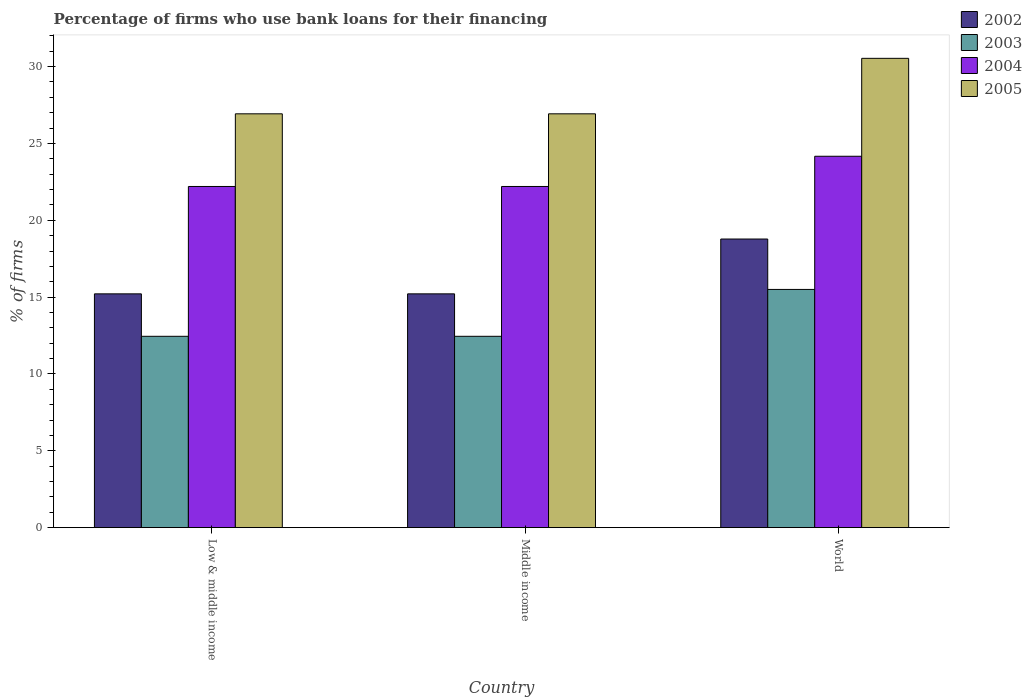How many different coloured bars are there?
Your answer should be very brief. 4. In how many cases, is the number of bars for a given country not equal to the number of legend labels?
Offer a very short reply. 0. What is the percentage of firms who use bank loans for their financing in 2003 in Low & middle income?
Offer a very short reply. 12.45. Across all countries, what is the maximum percentage of firms who use bank loans for their financing in 2003?
Your answer should be very brief. 15.5. Across all countries, what is the minimum percentage of firms who use bank loans for their financing in 2002?
Offer a very short reply. 15.21. In which country was the percentage of firms who use bank loans for their financing in 2003 maximum?
Provide a succinct answer. World. In which country was the percentage of firms who use bank loans for their financing in 2003 minimum?
Offer a terse response. Low & middle income. What is the total percentage of firms who use bank loans for their financing in 2005 in the graph?
Make the answer very short. 84.39. What is the difference between the percentage of firms who use bank loans for their financing in 2005 in Low & middle income and that in World?
Your answer should be compact. -3.61. What is the difference between the percentage of firms who use bank loans for their financing in 2005 in World and the percentage of firms who use bank loans for their financing in 2003 in Low & middle income?
Keep it short and to the point. 18.09. What is the average percentage of firms who use bank loans for their financing in 2004 per country?
Keep it short and to the point. 22.86. What is the difference between the percentage of firms who use bank loans for their financing of/in 2003 and percentage of firms who use bank loans for their financing of/in 2005 in Middle income?
Provide a succinct answer. -14.48. What is the ratio of the percentage of firms who use bank loans for their financing in 2003 in Low & middle income to that in World?
Keep it short and to the point. 0.8. What is the difference between the highest and the second highest percentage of firms who use bank loans for their financing in 2005?
Offer a terse response. -3.61. What is the difference between the highest and the lowest percentage of firms who use bank loans for their financing in 2004?
Keep it short and to the point. 1.97. Is the sum of the percentage of firms who use bank loans for their financing in 2005 in Low & middle income and World greater than the maximum percentage of firms who use bank loans for their financing in 2004 across all countries?
Keep it short and to the point. Yes. What does the 2nd bar from the right in Low & middle income represents?
Make the answer very short. 2004. Is it the case that in every country, the sum of the percentage of firms who use bank loans for their financing in 2003 and percentage of firms who use bank loans for their financing in 2005 is greater than the percentage of firms who use bank loans for their financing in 2004?
Ensure brevity in your answer.  Yes. What is the difference between two consecutive major ticks on the Y-axis?
Your answer should be very brief. 5. How many legend labels are there?
Your answer should be very brief. 4. How are the legend labels stacked?
Give a very brief answer. Vertical. What is the title of the graph?
Provide a succinct answer. Percentage of firms who use bank loans for their financing. Does "2000" appear as one of the legend labels in the graph?
Offer a terse response. No. What is the label or title of the Y-axis?
Your response must be concise. % of firms. What is the % of firms of 2002 in Low & middle income?
Your response must be concise. 15.21. What is the % of firms in 2003 in Low & middle income?
Ensure brevity in your answer.  12.45. What is the % of firms of 2005 in Low & middle income?
Make the answer very short. 26.93. What is the % of firms of 2002 in Middle income?
Your answer should be compact. 15.21. What is the % of firms in 2003 in Middle income?
Give a very brief answer. 12.45. What is the % of firms of 2004 in Middle income?
Provide a short and direct response. 22.2. What is the % of firms in 2005 in Middle income?
Your answer should be very brief. 26.93. What is the % of firms of 2002 in World?
Your answer should be very brief. 18.78. What is the % of firms in 2004 in World?
Provide a succinct answer. 24.17. What is the % of firms of 2005 in World?
Provide a short and direct response. 30.54. Across all countries, what is the maximum % of firms in 2002?
Provide a short and direct response. 18.78. Across all countries, what is the maximum % of firms of 2003?
Provide a succinct answer. 15.5. Across all countries, what is the maximum % of firms in 2004?
Offer a terse response. 24.17. Across all countries, what is the maximum % of firms in 2005?
Your response must be concise. 30.54. Across all countries, what is the minimum % of firms in 2002?
Your answer should be very brief. 15.21. Across all countries, what is the minimum % of firms of 2003?
Offer a very short reply. 12.45. Across all countries, what is the minimum % of firms of 2005?
Offer a very short reply. 26.93. What is the total % of firms of 2002 in the graph?
Provide a short and direct response. 49.21. What is the total % of firms in 2003 in the graph?
Your answer should be compact. 40.4. What is the total % of firms in 2004 in the graph?
Give a very brief answer. 68.57. What is the total % of firms in 2005 in the graph?
Offer a very short reply. 84.39. What is the difference between the % of firms in 2004 in Low & middle income and that in Middle income?
Provide a short and direct response. 0. What is the difference between the % of firms of 2002 in Low & middle income and that in World?
Your answer should be very brief. -3.57. What is the difference between the % of firms in 2003 in Low & middle income and that in World?
Make the answer very short. -3.05. What is the difference between the % of firms in 2004 in Low & middle income and that in World?
Give a very brief answer. -1.97. What is the difference between the % of firms of 2005 in Low & middle income and that in World?
Your answer should be very brief. -3.61. What is the difference between the % of firms of 2002 in Middle income and that in World?
Offer a very short reply. -3.57. What is the difference between the % of firms in 2003 in Middle income and that in World?
Offer a terse response. -3.05. What is the difference between the % of firms in 2004 in Middle income and that in World?
Your response must be concise. -1.97. What is the difference between the % of firms of 2005 in Middle income and that in World?
Provide a short and direct response. -3.61. What is the difference between the % of firms of 2002 in Low & middle income and the % of firms of 2003 in Middle income?
Provide a succinct answer. 2.76. What is the difference between the % of firms in 2002 in Low & middle income and the % of firms in 2004 in Middle income?
Offer a terse response. -6.99. What is the difference between the % of firms in 2002 in Low & middle income and the % of firms in 2005 in Middle income?
Provide a succinct answer. -11.72. What is the difference between the % of firms in 2003 in Low & middle income and the % of firms in 2004 in Middle income?
Your answer should be very brief. -9.75. What is the difference between the % of firms of 2003 in Low & middle income and the % of firms of 2005 in Middle income?
Your response must be concise. -14.48. What is the difference between the % of firms of 2004 in Low & middle income and the % of firms of 2005 in Middle income?
Provide a succinct answer. -4.73. What is the difference between the % of firms of 2002 in Low & middle income and the % of firms of 2003 in World?
Your answer should be very brief. -0.29. What is the difference between the % of firms in 2002 in Low & middle income and the % of firms in 2004 in World?
Make the answer very short. -8.95. What is the difference between the % of firms in 2002 in Low & middle income and the % of firms in 2005 in World?
Keep it short and to the point. -15.33. What is the difference between the % of firms in 2003 in Low & middle income and the % of firms in 2004 in World?
Offer a very short reply. -11.72. What is the difference between the % of firms in 2003 in Low & middle income and the % of firms in 2005 in World?
Ensure brevity in your answer.  -18.09. What is the difference between the % of firms in 2004 in Low & middle income and the % of firms in 2005 in World?
Offer a very short reply. -8.34. What is the difference between the % of firms of 2002 in Middle income and the % of firms of 2003 in World?
Offer a very short reply. -0.29. What is the difference between the % of firms of 2002 in Middle income and the % of firms of 2004 in World?
Offer a terse response. -8.95. What is the difference between the % of firms of 2002 in Middle income and the % of firms of 2005 in World?
Make the answer very short. -15.33. What is the difference between the % of firms in 2003 in Middle income and the % of firms in 2004 in World?
Your response must be concise. -11.72. What is the difference between the % of firms of 2003 in Middle income and the % of firms of 2005 in World?
Make the answer very short. -18.09. What is the difference between the % of firms in 2004 in Middle income and the % of firms in 2005 in World?
Ensure brevity in your answer.  -8.34. What is the average % of firms of 2002 per country?
Keep it short and to the point. 16.4. What is the average % of firms of 2003 per country?
Ensure brevity in your answer.  13.47. What is the average % of firms in 2004 per country?
Offer a very short reply. 22.86. What is the average % of firms of 2005 per country?
Offer a terse response. 28.13. What is the difference between the % of firms of 2002 and % of firms of 2003 in Low & middle income?
Offer a very short reply. 2.76. What is the difference between the % of firms of 2002 and % of firms of 2004 in Low & middle income?
Your answer should be very brief. -6.99. What is the difference between the % of firms in 2002 and % of firms in 2005 in Low & middle income?
Your response must be concise. -11.72. What is the difference between the % of firms of 2003 and % of firms of 2004 in Low & middle income?
Give a very brief answer. -9.75. What is the difference between the % of firms in 2003 and % of firms in 2005 in Low & middle income?
Offer a very short reply. -14.48. What is the difference between the % of firms in 2004 and % of firms in 2005 in Low & middle income?
Offer a terse response. -4.73. What is the difference between the % of firms in 2002 and % of firms in 2003 in Middle income?
Offer a terse response. 2.76. What is the difference between the % of firms in 2002 and % of firms in 2004 in Middle income?
Provide a short and direct response. -6.99. What is the difference between the % of firms in 2002 and % of firms in 2005 in Middle income?
Ensure brevity in your answer.  -11.72. What is the difference between the % of firms of 2003 and % of firms of 2004 in Middle income?
Give a very brief answer. -9.75. What is the difference between the % of firms of 2003 and % of firms of 2005 in Middle income?
Offer a terse response. -14.48. What is the difference between the % of firms of 2004 and % of firms of 2005 in Middle income?
Your answer should be compact. -4.73. What is the difference between the % of firms of 2002 and % of firms of 2003 in World?
Give a very brief answer. 3.28. What is the difference between the % of firms in 2002 and % of firms in 2004 in World?
Give a very brief answer. -5.39. What is the difference between the % of firms in 2002 and % of firms in 2005 in World?
Ensure brevity in your answer.  -11.76. What is the difference between the % of firms of 2003 and % of firms of 2004 in World?
Your response must be concise. -8.67. What is the difference between the % of firms in 2003 and % of firms in 2005 in World?
Ensure brevity in your answer.  -15.04. What is the difference between the % of firms of 2004 and % of firms of 2005 in World?
Give a very brief answer. -6.37. What is the ratio of the % of firms of 2002 in Low & middle income to that in Middle income?
Make the answer very short. 1. What is the ratio of the % of firms of 2002 in Low & middle income to that in World?
Offer a terse response. 0.81. What is the ratio of the % of firms of 2003 in Low & middle income to that in World?
Provide a short and direct response. 0.8. What is the ratio of the % of firms of 2004 in Low & middle income to that in World?
Keep it short and to the point. 0.92. What is the ratio of the % of firms in 2005 in Low & middle income to that in World?
Keep it short and to the point. 0.88. What is the ratio of the % of firms of 2002 in Middle income to that in World?
Your response must be concise. 0.81. What is the ratio of the % of firms in 2003 in Middle income to that in World?
Provide a succinct answer. 0.8. What is the ratio of the % of firms of 2004 in Middle income to that in World?
Your response must be concise. 0.92. What is the ratio of the % of firms of 2005 in Middle income to that in World?
Your answer should be compact. 0.88. What is the difference between the highest and the second highest % of firms of 2002?
Offer a very short reply. 3.57. What is the difference between the highest and the second highest % of firms in 2003?
Provide a short and direct response. 3.05. What is the difference between the highest and the second highest % of firms of 2004?
Give a very brief answer. 1.97. What is the difference between the highest and the second highest % of firms in 2005?
Provide a short and direct response. 3.61. What is the difference between the highest and the lowest % of firms of 2002?
Offer a terse response. 3.57. What is the difference between the highest and the lowest % of firms of 2003?
Make the answer very short. 3.05. What is the difference between the highest and the lowest % of firms in 2004?
Your answer should be very brief. 1.97. What is the difference between the highest and the lowest % of firms of 2005?
Ensure brevity in your answer.  3.61. 